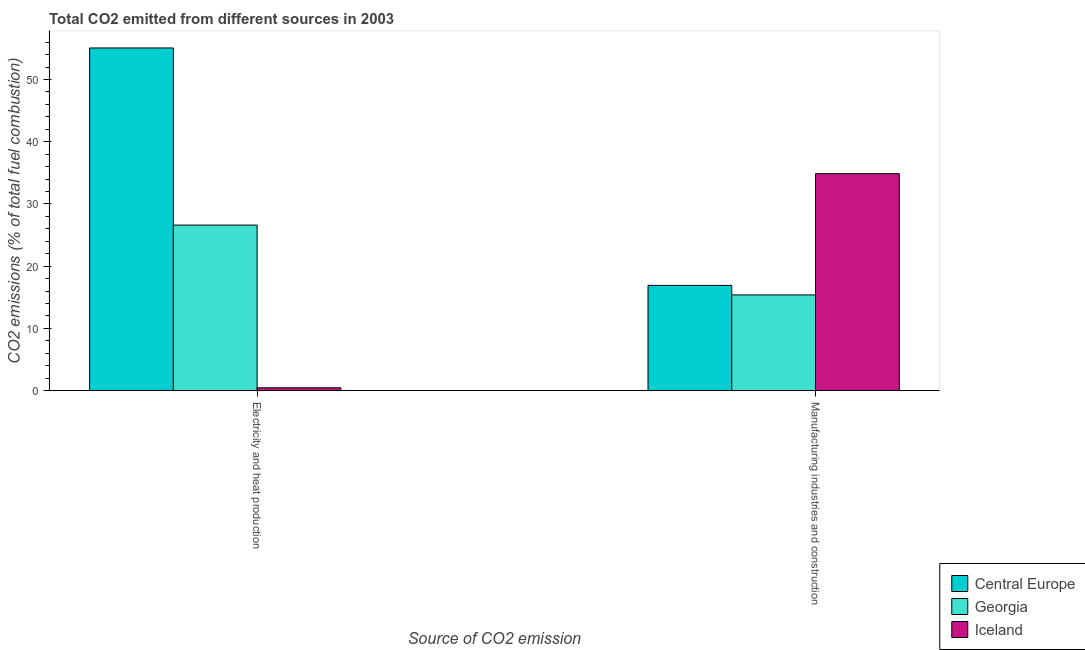Are the number of bars on each tick of the X-axis equal?
Offer a very short reply. Yes. What is the label of the 2nd group of bars from the left?
Provide a short and direct response. Manufacturing industries and construction. What is the co2 emissions due to electricity and heat production in Georgia?
Ensure brevity in your answer.  26.6. Across all countries, what is the maximum co2 emissions due to electricity and heat production?
Your response must be concise. 55.06. Across all countries, what is the minimum co2 emissions due to electricity and heat production?
Ensure brevity in your answer.  0.46. In which country was the co2 emissions due to manufacturing industries minimum?
Ensure brevity in your answer.  Georgia. What is the total co2 emissions due to electricity and heat production in the graph?
Your response must be concise. 82.12. What is the difference between the co2 emissions due to electricity and heat production in Central Europe and that in Georgia?
Offer a terse response. 28.46. What is the difference between the co2 emissions due to manufacturing industries in Iceland and the co2 emissions due to electricity and heat production in Georgia?
Offer a very short reply. 8.26. What is the average co2 emissions due to electricity and heat production per country?
Keep it short and to the point. 27.37. What is the difference between the co2 emissions due to electricity and heat production and co2 emissions due to manufacturing industries in Central Europe?
Make the answer very short. 38.15. In how many countries, is the co2 emissions due to manufacturing industries greater than 24 %?
Ensure brevity in your answer.  1. What is the ratio of the co2 emissions due to electricity and heat production in Central Europe to that in Iceland?
Make the answer very short. 120.03. Is the co2 emissions due to electricity and heat production in Central Europe less than that in Georgia?
Provide a succinct answer. No. In how many countries, is the co2 emissions due to electricity and heat production greater than the average co2 emissions due to electricity and heat production taken over all countries?
Your answer should be very brief. 1. What does the 2nd bar from the left in Electricity and heat production represents?
Provide a short and direct response. Georgia. What does the 1st bar from the right in Electricity and heat production represents?
Offer a terse response. Iceland. Are all the bars in the graph horizontal?
Ensure brevity in your answer.  No. How many countries are there in the graph?
Offer a terse response. 3. Are the values on the major ticks of Y-axis written in scientific E-notation?
Provide a succinct answer. No. Does the graph contain any zero values?
Offer a terse response. No. What is the title of the graph?
Provide a succinct answer. Total CO2 emitted from different sources in 2003. What is the label or title of the X-axis?
Make the answer very short. Source of CO2 emission. What is the label or title of the Y-axis?
Your response must be concise. CO2 emissions (% of total fuel combustion). What is the CO2 emissions (% of total fuel combustion) in Central Europe in Electricity and heat production?
Offer a very short reply. 55.06. What is the CO2 emissions (% of total fuel combustion) in Georgia in Electricity and heat production?
Make the answer very short. 26.6. What is the CO2 emissions (% of total fuel combustion) of Iceland in Electricity and heat production?
Your answer should be compact. 0.46. What is the CO2 emissions (% of total fuel combustion) in Central Europe in Manufacturing industries and construction?
Keep it short and to the point. 16.91. What is the CO2 emissions (% of total fuel combustion) in Georgia in Manufacturing industries and construction?
Provide a succinct answer. 15.38. What is the CO2 emissions (% of total fuel combustion) in Iceland in Manufacturing industries and construction?
Provide a short and direct response. 34.86. Across all Source of CO2 emission, what is the maximum CO2 emissions (% of total fuel combustion) in Central Europe?
Provide a succinct answer. 55.06. Across all Source of CO2 emission, what is the maximum CO2 emissions (% of total fuel combustion) in Georgia?
Offer a terse response. 26.6. Across all Source of CO2 emission, what is the maximum CO2 emissions (% of total fuel combustion) in Iceland?
Provide a succinct answer. 34.86. Across all Source of CO2 emission, what is the minimum CO2 emissions (% of total fuel combustion) in Central Europe?
Your response must be concise. 16.91. Across all Source of CO2 emission, what is the minimum CO2 emissions (% of total fuel combustion) of Georgia?
Give a very brief answer. 15.38. Across all Source of CO2 emission, what is the minimum CO2 emissions (% of total fuel combustion) in Iceland?
Your answer should be very brief. 0.46. What is the total CO2 emissions (% of total fuel combustion) of Central Europe in the graph?
Ensure brevity in your answer.  71.97. What is the total CO2 emissions (% of total fuel combustion) in Georgia in the graph?
Offer a very short reply. 41.99. What is the total CO2 emissions (% of total fuel combustion) in Iceland in the graph?
Give a very brief answer. 35.32. What is the difference between the CO2 emissions (% of total fuel combustion) of Central Europe in Electricity and heat production and that in Manufacturing industries and construction?
Give a very brief answer. 38.15. What is the difference between the CO2 emissions (% of total fuel combustion) in Georgia in Electricity and heat production and that in Manufacturing industries and construction?
Your answer should be very brief. 11.22. What is the difference between the CO2 emissions (% of total fuel combustion) of Iceland in Electricity and heat production and that in Manufacturing industries and construction?
Your response must be concise. -34.4. What is the difference between the CO2 emissions (% of total fuel combustion) in Central Europe in Electricity and heat production and the CO2 emissions (% of total fuel combustion) in Georgia in Manufacturing industries and construction?
Your answer should be very brief. 39.67. What is the difference between the CO2 emissions (% of total fuel combustion) in Central Europe in Electricity and heat production and the CO2 emissions (% of total fuel combustion) in Iceland in Manufacturing industries and construction?
Give a very brief answer. 20.2. What is the difference between the CO2 emissions (% of total fuel combustion) of Georgia in Electricity and heat production and the CO2 emissions (% of total fuel combustion) of Iceland in Manufacturing industries and construction?
Your response must be concise. -8.26. What is the average CO2 emissions (% of total fuel combustion) of Central Europe per Source of CO2 emission?
Keep it short and to the point. 35.99. What is the average CO2 emissions (% of total fuel combustion) of Georgia per Source of CO2 emission?
Ensure brevity in your answer.  20.99. What is the average CO2 emissions (% of total fuel combustion) in Iceland per Source of CO2 emission?
Keep it short and to the point. 17.66. What is the difference between the CO2 emissions (% of total fuel combustion) in Central Europe and CO2 emissions (% of total fuel combustion) in Georgia in Electricity and heat production?
Your response must be concise. 28.46. What is the difference between the CO2 emissions (% of total fuel combustion) of Central Europe and CO2 emissions (% of total fuel combustion) of Iceland in Electricity and heat production?
Your answer should be compact. 54.6. What is the difference between the CO2 emissions (% of total fuel combustion) of Georgia and CO2 emissions (% of total fuel combustion) of Iceland in Electricity and heat production?
Make the answer very short. 26.14. What is the difference between the CO2 emissions (% of total fuel combustion) of Central Europe and CO2 emissions (% of total fuel combustion) of Georgia in Manufacturing industries and construction?
Offer a terse response. 1.53. What is the difference between the CO2 emissions (% of total fuel combustion) in Central Europe and CO2 emissions (% of total fuel combustion) in Iceland in Manufacturing industries and construction?
Ensure brevity in your answer.  -17.95. What is the difference between the CO2 emissions (% of total fuel combustion) in Georgia and CO2 emissions (% of total fuel combustion) in Iceland in Manufacturing industries and construction?
Your answer should be very brief. -19.48. What is the ratio of the CO2 emissions (% of total fuel combustion) in Central Europe in Electricity and heat production to that in Manufacturing industries and construction?
Offer a very short reply. 3.26. What is the ratio of the CO2 emissions (% of total fuel combustion) of Georgia in Electricity and heat production to that in Manufacturing industries and construction?
Give a very brief answer. 1.73. What is the ratio of the CO2 emissions (% of total fuel combustion) in Iceland in Electricity and heat production to that in Manufacturing industries and construction?
Provide a short and direct response. 0.01. What is the difference between the highest and the second highest CO2 emissions (% of total fuel combustion) of Central Europe?
Ensure brevity in your answer.  38.15. What is the difference between the highest and the second highest CO2 emissions (% of total fuel combustion) in Georgia?
Ensure brevity in your answer.  11.22. What is the difference between the highest and the second highest CO2 emissions (% of total fuel combustion) in Iceland?
Ensure brevity in your answer.  34.4. What is the difference between the highest and the lowest CO2 emissions (% of total fuel combustion) of Central Europe?
Your answer should be very brief. 38.15. What is the difference between the highest and the lowest CO2 emissions (% of total fuel combustion) in Georgia?
Provide a short and direct response. 11.22. What is the difference between the highest and the lowest CO2 emissions (% of total fuel combustion) in Iceland?
Provide a succinct answer. 34.4. 